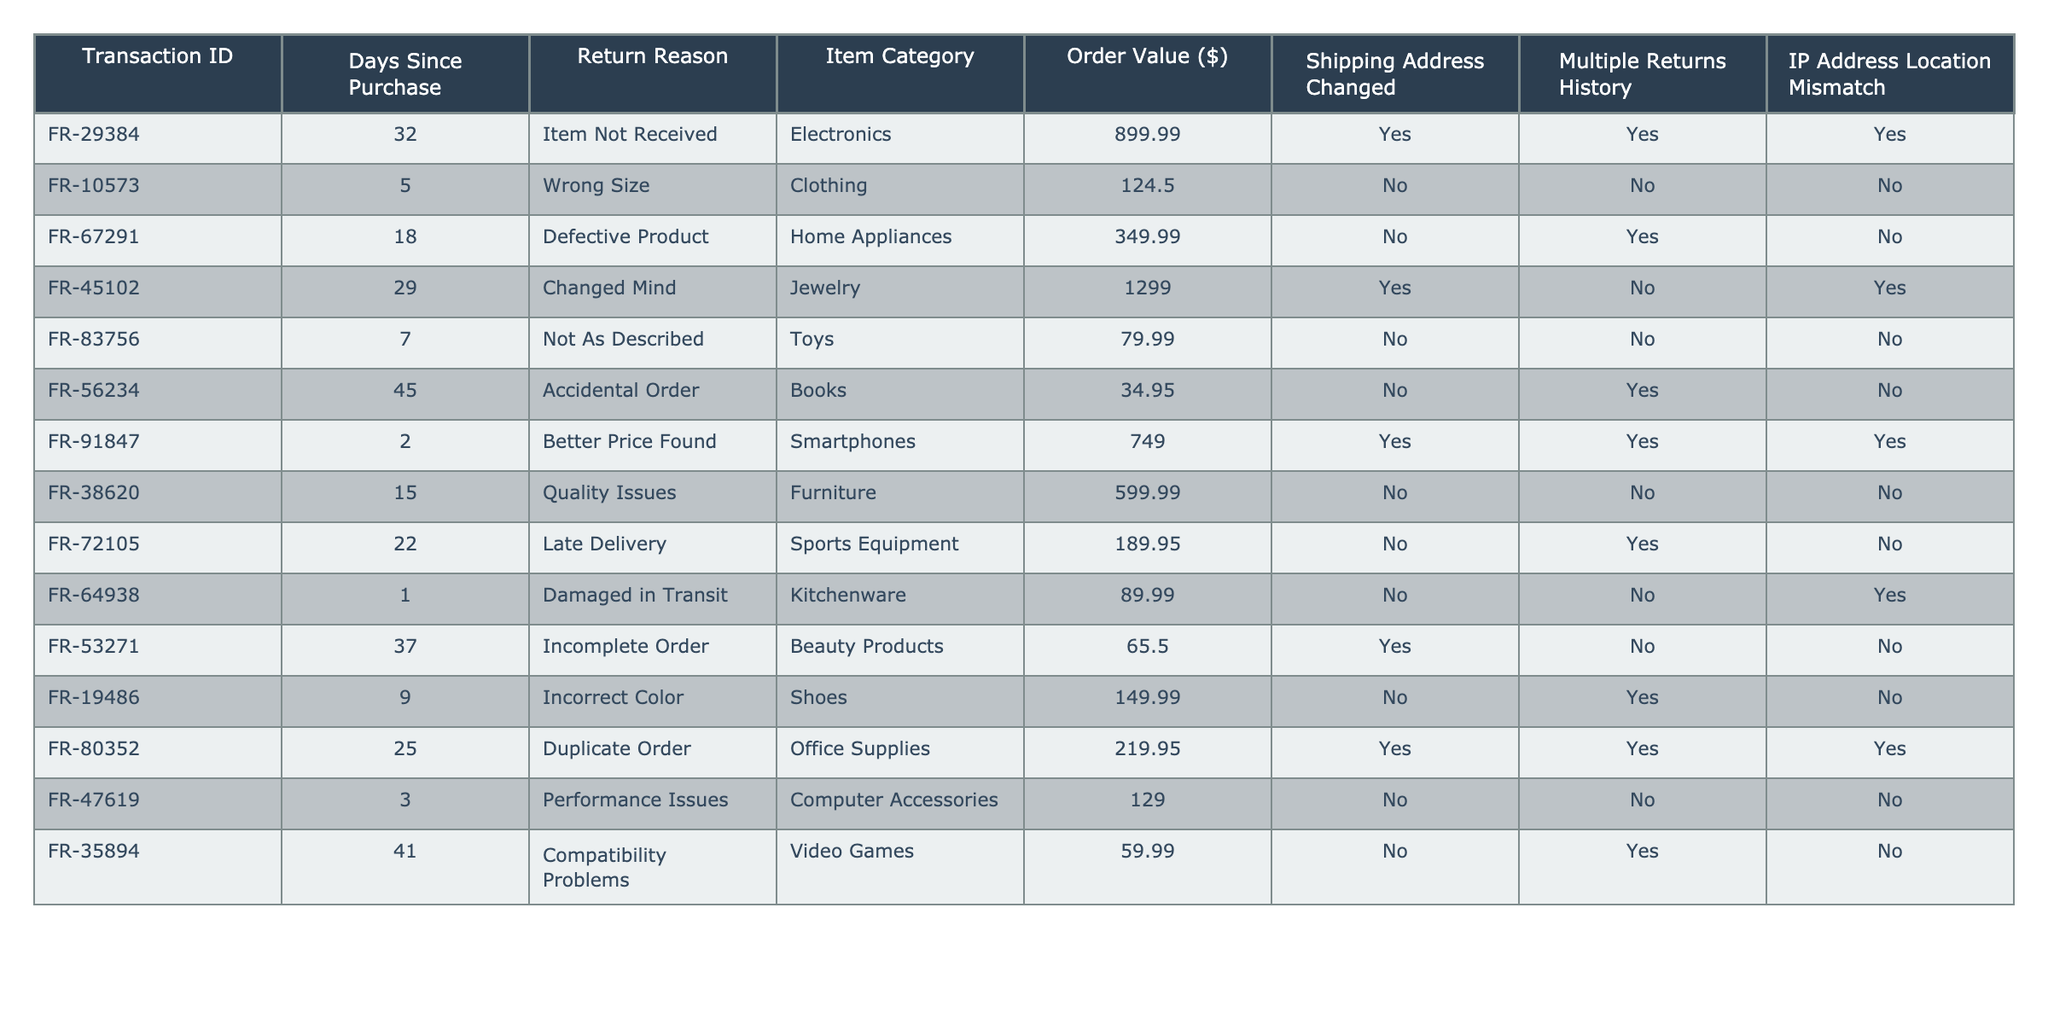What is the return reason for Transaction ID FR-29384? The return reason is listed directly in the table under the "Return Reason" column. For Transaction ID FR-29384, the return reason is "Item Not Received."
Answer: Item Not Received How many transactions have a shipping address change? To find this, we count the entries in the "Shipping Address Changed" column that show "Yes." There are five transactions with a shipping address change.
Answer: 5 What is the total order value for transactions classified under "Electronics"? We look for entries in the "Item Category" column that are "Electronics." The corresponding order value for Transaction ID FR-29384 is 899.99. Thus, the total order value for Electronics is 899.99.
Answer: 899.99 How many transactions have been marked as having multiple returns history? We count the instances of "Yes" in the "Multiple Returns History" column. Upon checking, there are four transactions that have multiple returns history.
Answer: 4 Which transaction had a late delivery as the return reason, and what was its order value? We search the "Return Reason" column for "Late Delivery" and find it corresponds to Transaction ID FR-72105. The order value for this transaction is 189.95.
Answer: FR-72105, 189.95 What percentage of transactions involved product issues (Defective Product, Quality Issues, Compatibility Problems)? First, we identify transactions that fall under product issues: FR-67291, FR-38620, and FR-35894, totaling three transactions. With ten transactions overall, the percentage of issues is (3/10)*100 = 30%.
Answer: 30% Which item category has the highest order value, and what is it? We examine the "Order Value ($)" for each item category and find that Jewelry (in Transaction ID FR-45102) has the highest order value at 1299.00.
Answer: Jewelry, 1299.00 Is there a transaction with an IP address location mismatch that also has a shipping address change? By checking for "Yes" under both "IP Address Location Mismatch" and "Shipping Address Changed," we find that Transaction ID FR-29384 and FR-91847 both meet this criterion.
Answer: Yes What is the average order value for transactions with a return reason of "Wrong Size"? We find the order value for Transaction ID FR-10573, which is 124.50. Since there is only one transaction in this category, the average is 124.50 itself.
Answer: 124.50 How many transactions resulted from customers simply changing their minds (Changed Mind)? We identify entry "Changed Mind" under "Return Reason" corresponding to Transaction ID FR-45102, which is the only instance, so the total is one.
Answer: 1 Which transactions were affected by damaged products during transit or delivery and what return reasons were they given? We look for "Damaged in Transit" and "Late Delivery." The affected transactions are FR-64938 ("Damaged in Transit") and FR-72105 ("Late Delivery").
Answer: FR-64938: Damaged in Transit, FR-72105: Late Delivery 